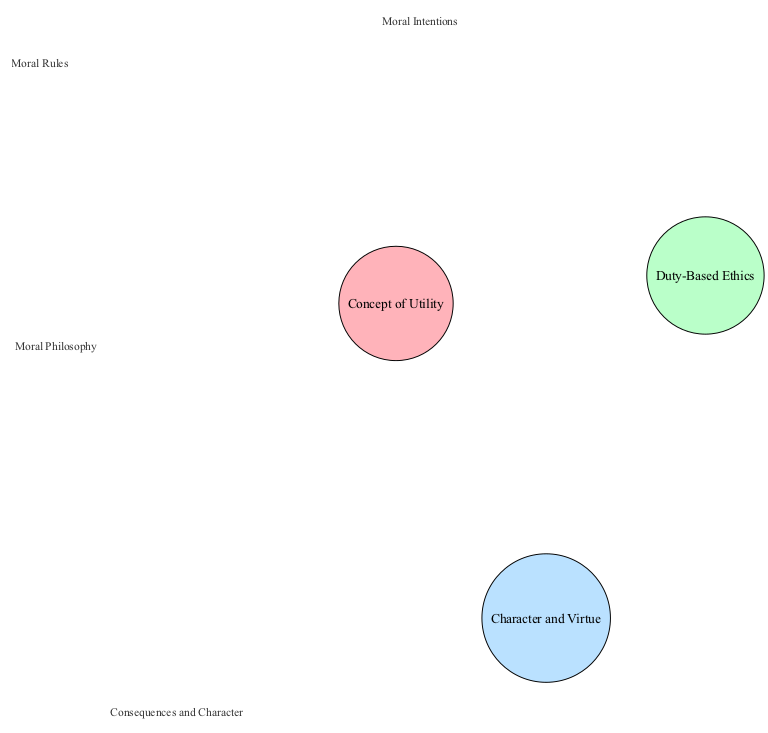What is the label of the Utilitarianism node? The Utilitarianism node is labeled "Concept of Utility" according to the data provided.
Answer: Concept of Utility How many main ethical theories are represented in the diagram? There are three main ethical theories represented: Utilitarianism, Deontology, and Virtue Ethics.
Answer: 3 What do the intersections of Utilitarianism and Deontology represent? The intersection of Utilitarianism and Deontology is labeled "Moral Rules," indicating a shared aspect of these two theories.
Answer: Moral Rules Which ethical theory focuses on character and virtue? The ethical theory that focuses on character and virtue is Virtue Ethics, as indicated by its specific label in the diagram.
Answer: Virtue Ethics What is the label for the intersection of all three theories? The intersection of Utilitarianism, Deontology, and Virtue Ethics is labeled "Moral Philosophy," showing a combined understanding of these ethics.
Answer: Moral Philosophy What color represents Deontology in the diagram? Deontology is represented by the color #BAFFC9, which is consistent throughout the diagram for this ethical theory.
Answer: #BAFFC9 How many intersections are there between the major ethical theories? There are four intersections between the theories: "Moral Rules," "Consequences and Character," "Moral Intentions," and "Moral Philosophy."
Answer: 4 What common aspect do Utilitarianism and Virtue Ethics share? Utilitarianism and Virtue Ethics share the aspect labeled "Consequences and Character," which highlights an intersection between the two theories.
Answer: Consequences and Character Which two theories intersect to represent "Moral Intentions"? "Moral Intentions" is the intersection of Deontology and Virtue Ethics, emphasizing the importance of intentions in ethical behavior.
Answer: Deontology and Virtue Ethics 